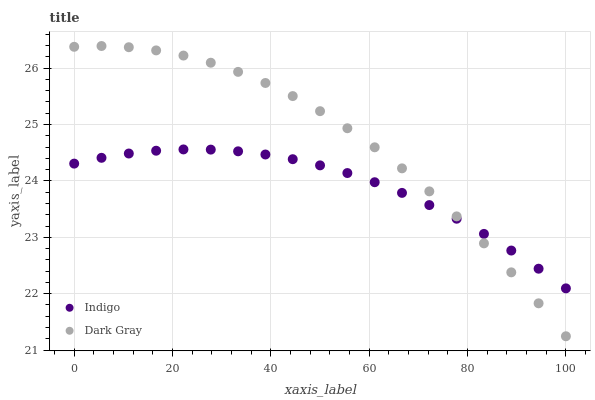Does Indigo have the minimum area under the curve?
Answer yes or no. Yes. Does Dark Gray have the maximum area under the curve?
Answer yes or no. Yes. Does Indigo have the maximum area under the curve?
Answer yes or no. No. Is Indigo the smoothest?
Answer yes or no. Yes. Is Dark Gray the roughest?
Answer yes or no. Yes. Is Indigo the roughest?
Answer yes or no. No. Does Dark Gray have the lowest value?
Answer yes or no. Yes. Does Indigo have the lowest value?
Answer yes or no. No. Does Dark Gray have the highest value?
Answer yes or no. Yes. Does Indigo have the highest value?
Answer yes or no. No. Does Indigo intersect Dark Gray?
Answer yes or no. Yes. Is Indigo less than Dark Gray?
Answer yes or no. No. Is Indigo greater than Dark Gray?
Answer yes or no. No. 